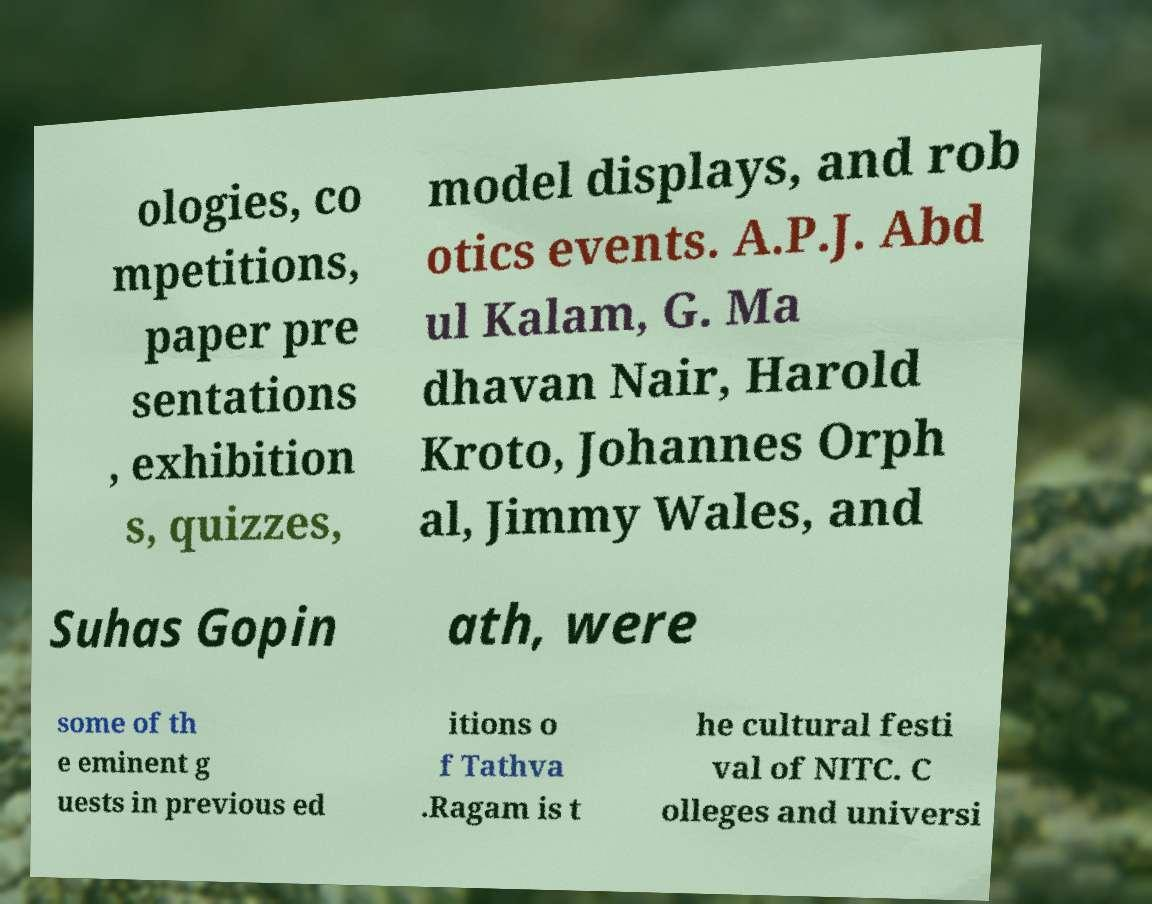There's text embedded in this image that I need extracted. Can you transcribe it verbatim? ologies, co mpetitions, paper pre sentations , exhibition s, quizzes, model displays, and rob otics events. A.P.J. Abd ul Kalam, G. Ma dhavan Nair, Harold Kroto, Johannes Orph al, Jimmy Wales, and Suhas Gopin ath, were some of th e eminent g uests in previous ed itions o f Tathva .Ragam is t he cultural festi val of NITC. C olleges and universi 